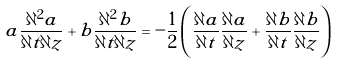<formula> <loc_0><loc_0><loc_500><loc_500>a \frac { \partial ^ { 2 } a } { \partial t \partial z } + b \frac { \partial ^ { 2 } b } { \partial t \partial z } = - \frac { 1 } { 2 } \left ( \frac { \partial a } { \partial t } \frac { \partial a } { \partial z } + \frac { \partial b } { \partial t } \frac { \partial b } { \partial z } \right )</formula> 